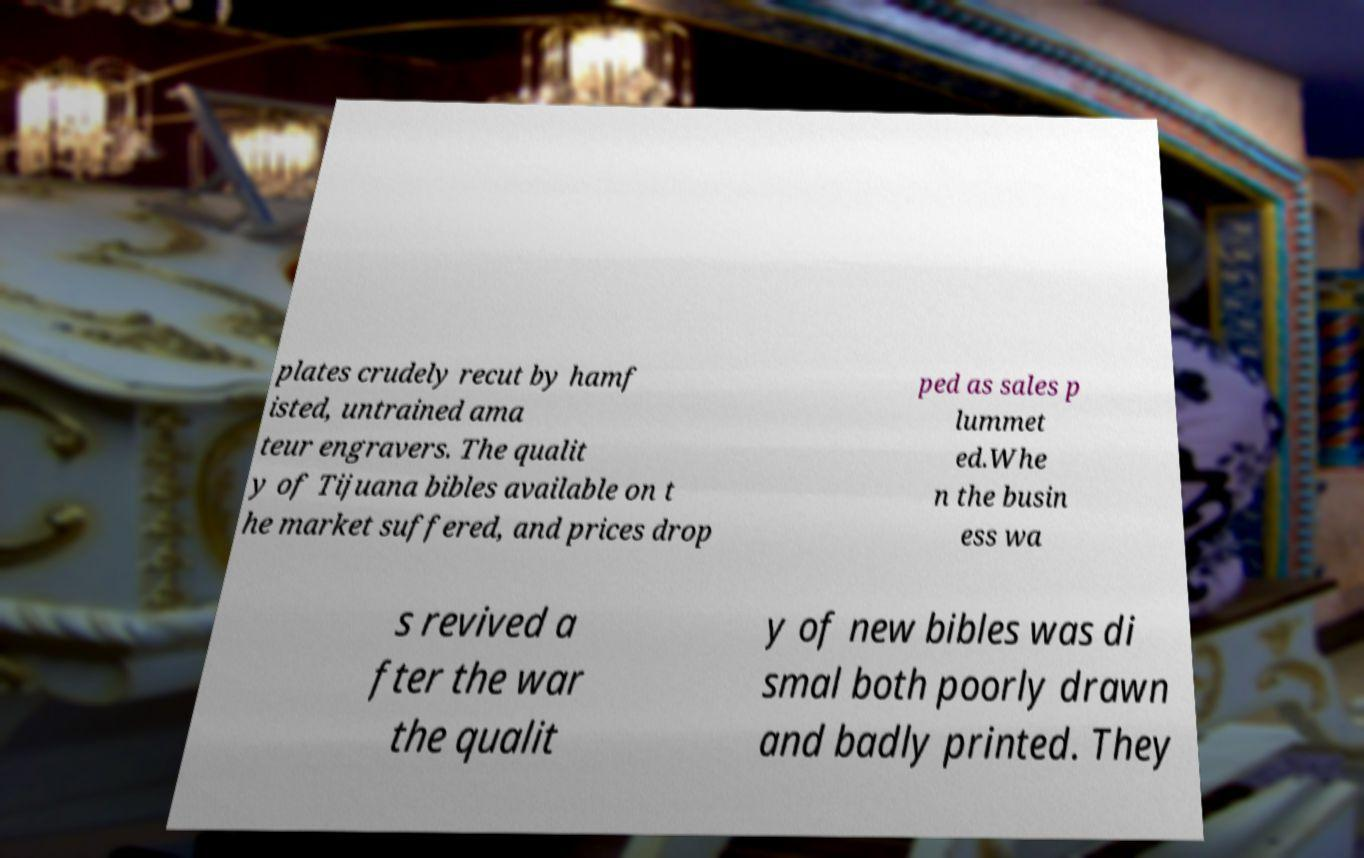Can you read and provide the text displayed in the image?This photo seems to have some interesting text. Can you extract and type it out for me? plates crudely recut by hamf isted, untrained ama teur engravers. The qualit y of Tijuana bibles available on t he market suffered, and prices drop ped as sales p lummet ed.Whe n the busin ess wa s revived a fter the war the qualit y of new bibles was di smal both poorly drawn and badly printed. They 